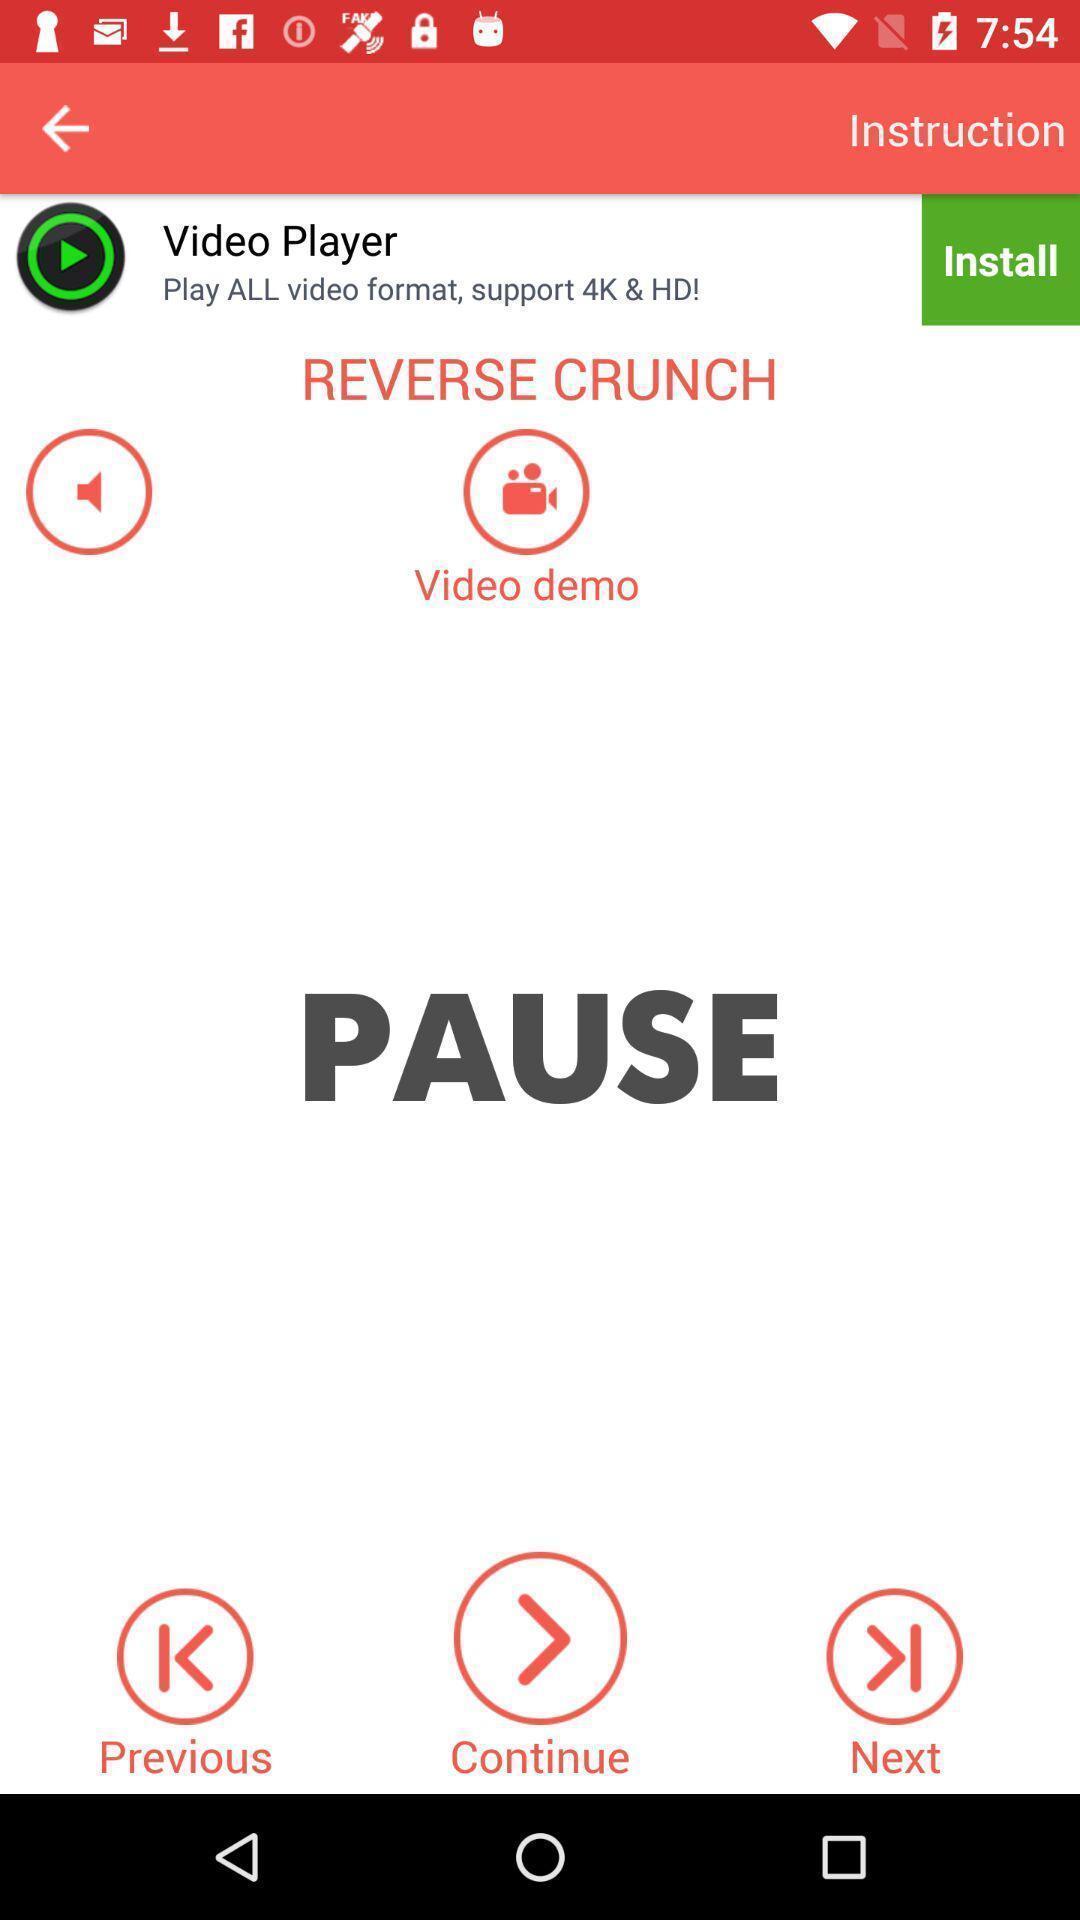Summarize the information in this screenshot. Page of a workout app with various options. 